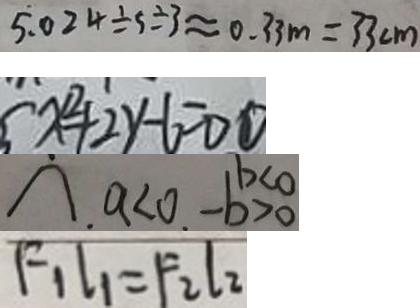<formula> <loc_0><loc_0><loc_500><loc_500>5 . 0 2 4 \div 5 \div 3 \approx 0 . 3 3 m = 3 3 c m 
 x ^ { 2 } + 2 y - 6 = 0 \textcircled { 1 } 
 \cap . a < 0 . - b > 0 
 F _ { 1 } l _ { 1 } = F _ { 2 } l _ { 2 }</formula> 